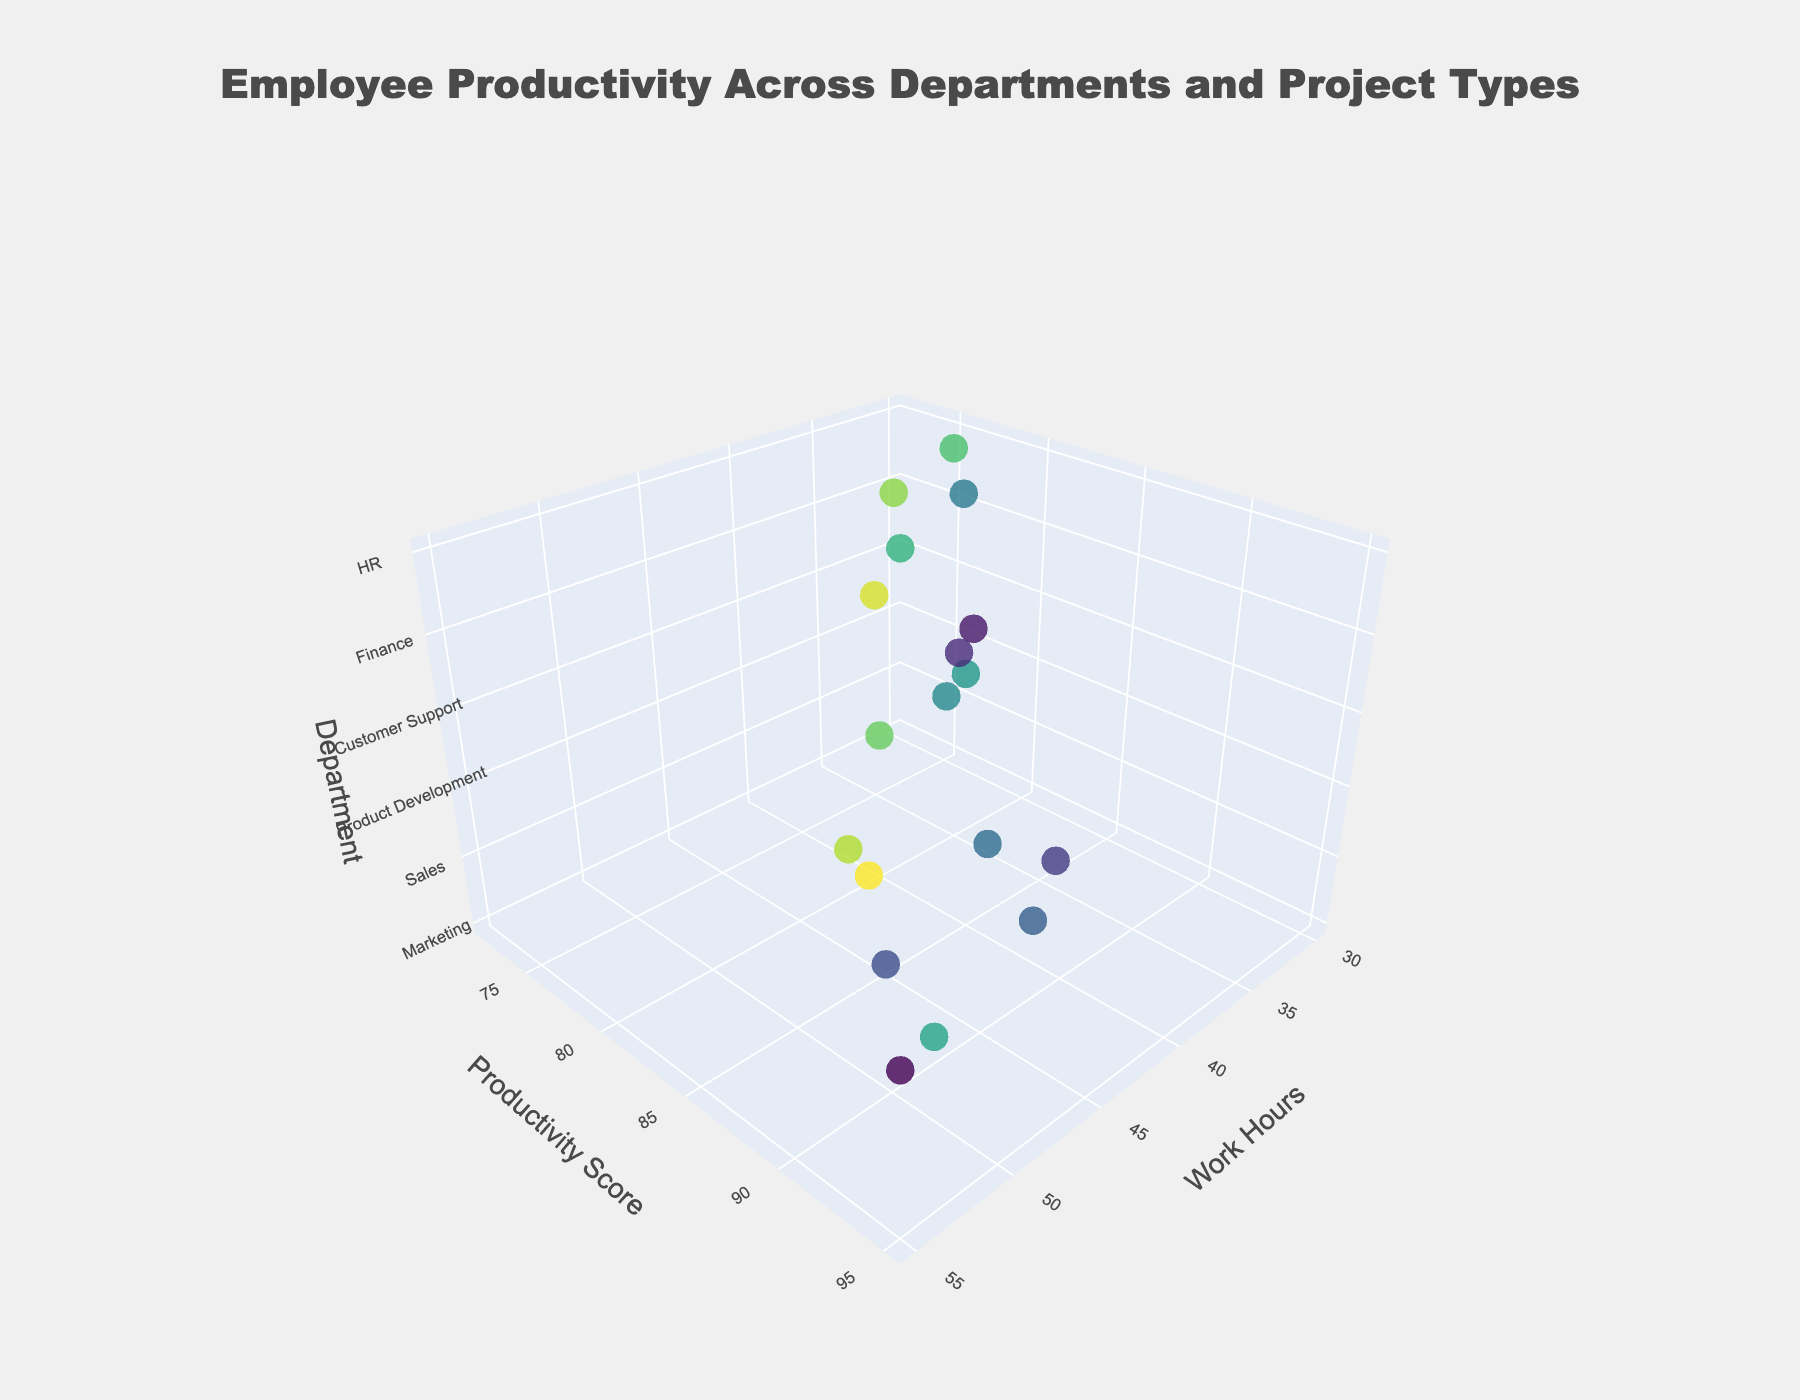How many departments are represented in the figure? The figure includes a department axis which clearly indicates different departments. Observe and count the number of unique department labels on this axis.
Answer: 5 What is the title of the figure? The plot's title is placed at the top center of the figure. Read the visible text in this area.
Answer: Employee Productivity Across Departments and Project Types Which department has the highest productivity score? Examine the Productivity Score axis, and identify the department associated with the highest point on this axis.
Answer: Sales How does productivity score for UI/UX Design compare to QA Testing within Product Development? Look for the data points labeled UI/UX Design and QA Testing within the Product Development department, and compare their productivity scores.
Answer: UI/UX Design has a higher productivity score What are the work hours for the live chat support project in Customer Support? Find the data point labeled Live Chat Support in the Customer Support department and check its position on the Work Hours axis.
Answer: 30 Which project type in Finance has the highest productivity score and how many work hours are associated with it? Within the Finance department, locate the project type with the highest productivity score and note its position on the Work Hours axis.
Answer: Financial Reporting, 45 What is the range of work hours covered by the projects in the Marketing department? Identify the minimum and maximum work hours for all Marketing department projects by examining their respective positions on the Work Hours axis.
Answer: 35 to 45 Compare the productivity scores of Email Marketing and Content Creation in the Marketing department. Which is higher? Locate the data points for Email Marketing and Content Creation within the Marketing department, then compare their positions on the Productivity Score axis.
Answer: Content Creation How many project types have a productivity score of 88? Check for project types that are plotted on the Productivity Score axis at the value of 88 and count them.
Answer: 2 Which project type has the lowest productivity score in the HR department and what is its productivity score? Within the HR department, find the project type with the lowest position on the Productivity Score axis and note its value.
Answer: Performance Reviews, 77 